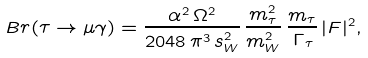Convert formula to latex. <formula><loc_0><loc_0><loc_500><loc_500>B r ( \tau \to \mu \gamma ) = \frac { { \alpha } ^ { 2 } \, { \Omega } ^ { 2 } } { 2 0 4 8 \, { \pi } ^ { 3 } \, s _ { W } ^ { 2 } } \, \frac { m _ { \tau } ^ { 2 } } { m _ { W } ^ { 2 } } \, \frac { m _ { \tau } } { \, \Gamma _ { \tau } } \, | F | ^ { 2 } ,</formula> 